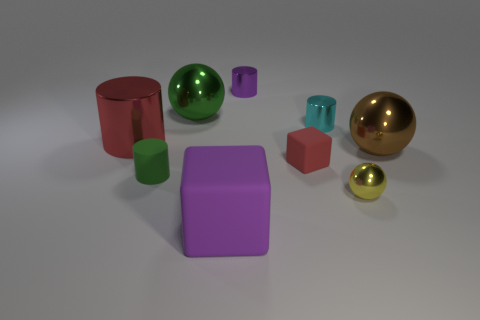Do the matte cylinder and the rubber object in front of the small yellow object have the same color?
Give a very brief answer. No. The large matte cube is what color?
Your answer should be compact. Purple. There is a small thing that is on the left side of the big purple object; what is its material?
Offer a very short reply. Rubber. What size is the yellow thing that is the same shape as the big green thing?
Provide a succinct answer. Small. Are there fewer cyan objects in front of the red cube than large green balls?
Provide a short and direct response. Yes. Are any green shiny balls visible?
Give a very brief answer. Yes. What color is the other rubber thing that is the same shape as the big red thing?
Offer a terse response. Green. Do the object behind the big green object and the big matte thing have the same color?
Offer a very short reply. Yes. Do the rubber cylinder and the red cylinder have the same size?
Provide a short and direct response. No. There is a cyan thing that is made of the same material as the small yellow ball; what is its shape?
Your answer should be compact. Cylinder. 